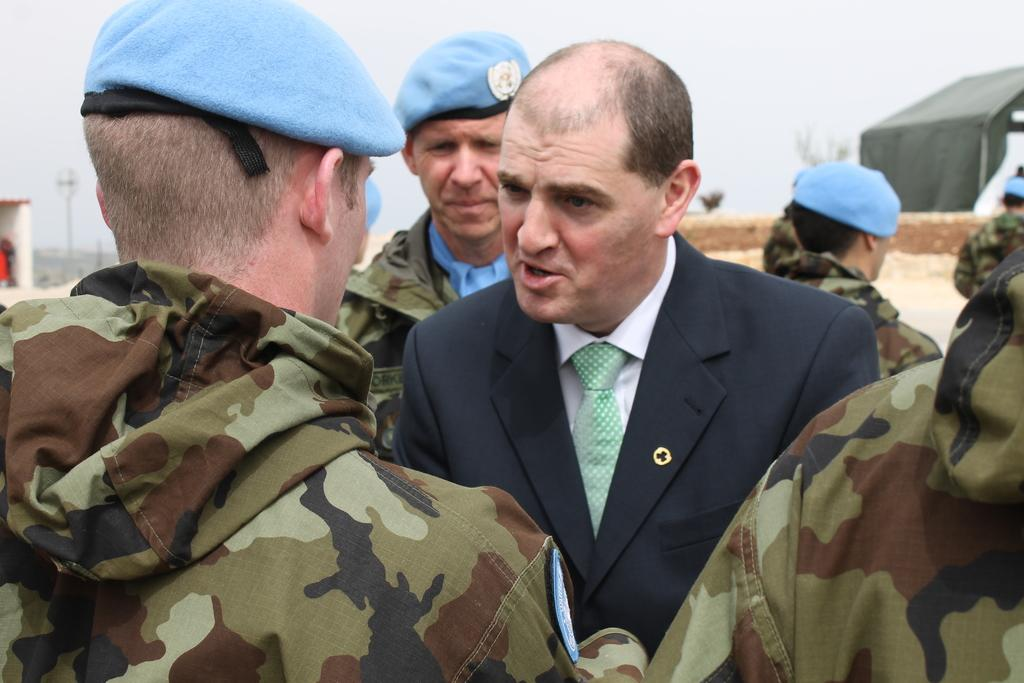Who or what can be seen in the image? There are people in the image. What are some of the people wearing? Some people are wearing caps. What can be seen in the background of the image? There are sheds and poles in the background of the image. What is visible at the top of the image? The sky is visible at the top of the image. Can you see a kitty playing with scissors in the image? No, there is no kitty or scissors present in the image. 